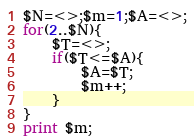Convert code to text. <code><loc_0><loc_0><loc_500><loc_500><_Perl_>$N=<>;$m=1;$A=<>;
for(2..$N){
    $T=<>;
    if($T<=$A){
        $A=$T;
        $m++;
    }
}
print $m;</code> 